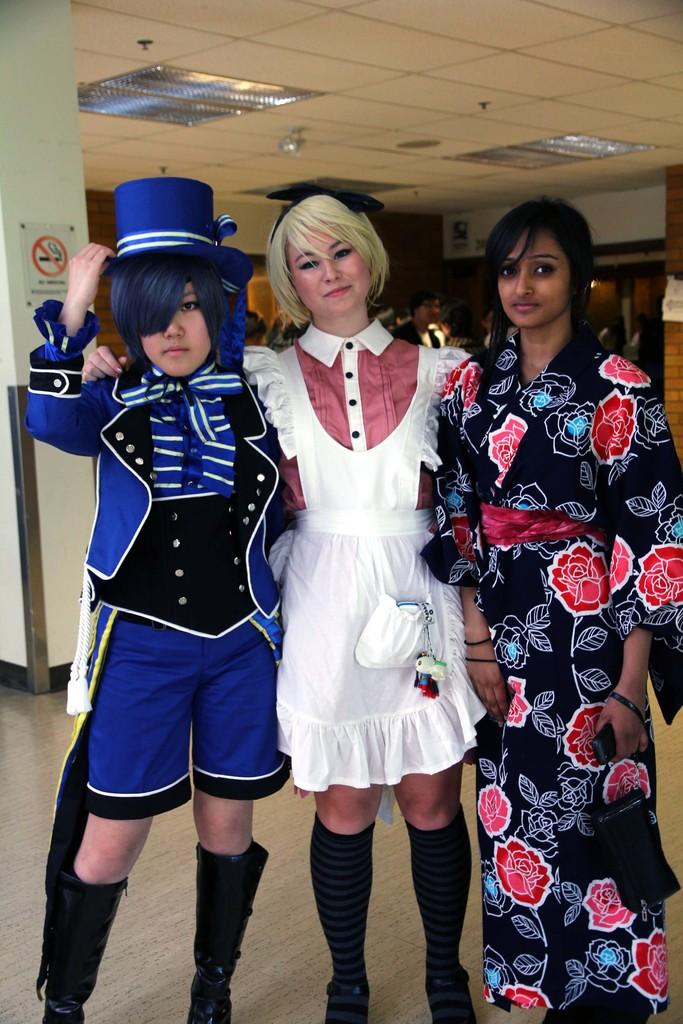How many people are in the image? There are three people standing in the center of the image. What can be seen in the background of the image? There is a building in the background of the image. What is visible at the top of the image? There are lights visible at the top of the image. What is visible at the bottom of the image? There is a floor visible at the bottom of the image. What type of sheet is covering the property in the image? There is no sheet or property present in the image. 